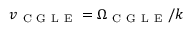Convert formula to latex. <formula><loc_0><loc_0><loc_500><loc_500>v _ { C G L E } = \Omega _ { C G L E } / k</formula> 